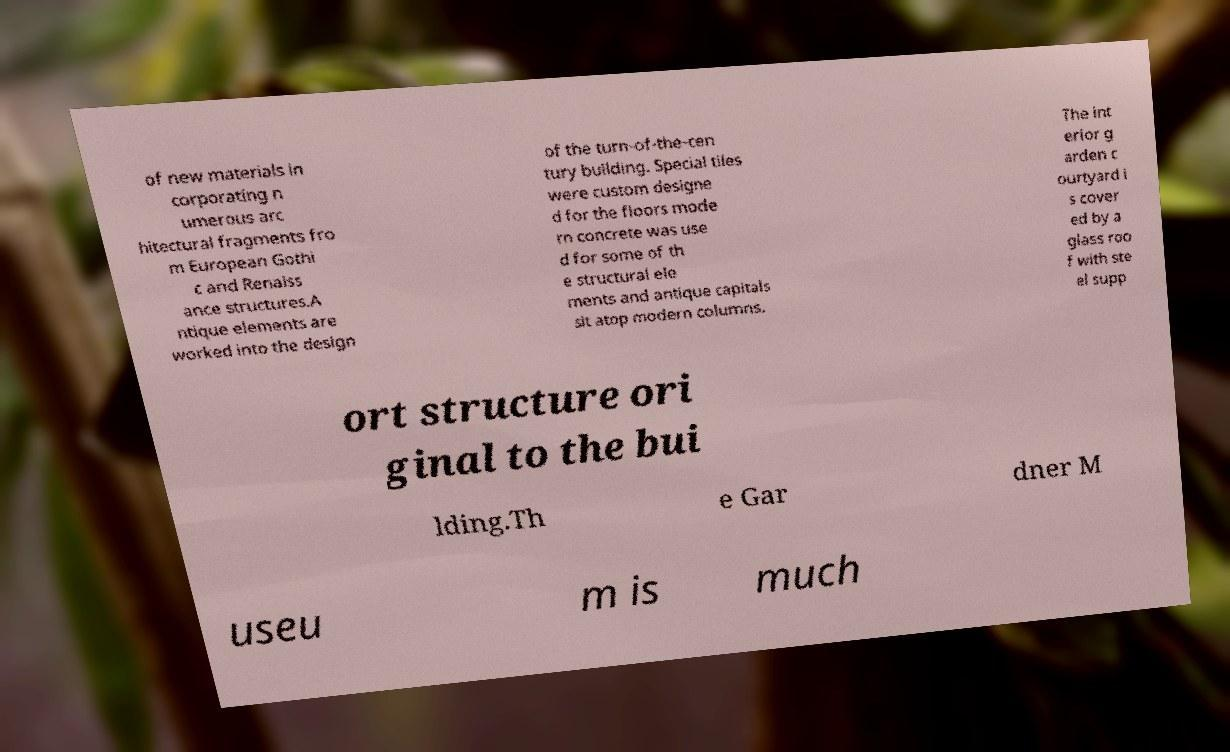Could you assist in decoding the text presented in this image and type it out clearly? of new materials in corporating n umerous arc hitectural fragments fro m European Gothi c and Renaiss ance structures.A ntique elements are worked into the design of the turn-of-the-cen tury building. Special tiles were custom designe d for the floors mode rn concrete was use d for some of th e structural ele ments and antique capitals sit atop modern columns. The int erior g arden c ourtyard i s cover ed by a glass roo f with ste el supp ort structure ori ginal to the bui lding.Th e Gar dner M useu m is much 